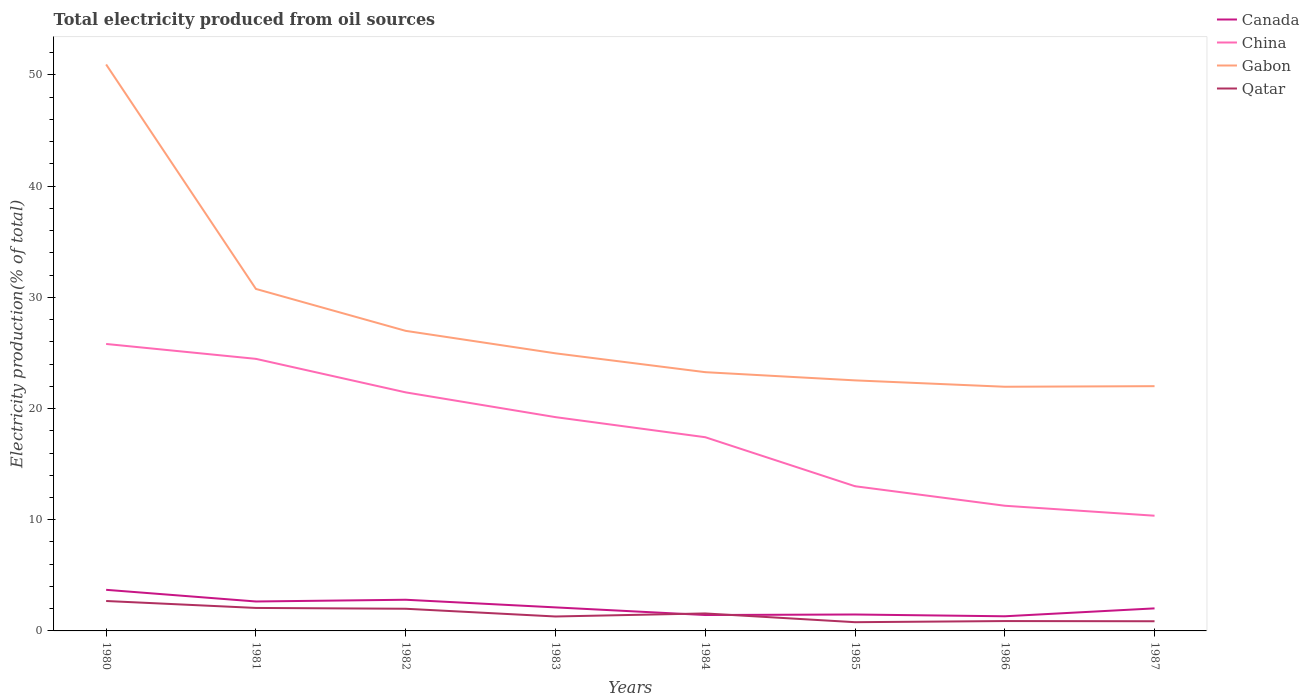How many different coloured lines are there?
Provide a succinct answer. 4. Does the line corresponding to China intersect with the line corresponding to Canada?
Offer a terse response. No. Is the number of lines equal to the number of legend labels?
Offer a very short reply. Yes. Across all years, what is the maximum total electricity produced in Gabon?
Give a very brief answer. 21.96. In which year was the total electricity produced in China maximum?
Offer a very short reply. 1987. What is the total total electricity produced in China in the graph?
Offer a very short reply. 8.87. What is the difference between the highest and the second highest total electricity produced in Canada?
Give a very brief answer. 2.38. Is the total electricity produced in Canada strictly greater than the total electricity produced in China over the years?
Provide a short and direct response. Yes. How many lines are there?
Ensure brevity in your answer.  4. How many years are there in the graph?
Your response must be concise. 8. What is the difference between two consecutive major ticks on the Y-axis?
Your answer should be compact. 10. How many legend labels are there?
Offer a very short reply. 4. What is the title of the graph?
Offer a very short reply. Total electricity produced from oil sources. Does "Jamaica" appear as one of the legend labels in the graph?
Offer a very short reply. No. What is the label or title of the X-axis?
Keep it short and to the point. Years. What is the label or title of the Y-axis?
Your answer should be very brief. Electricity production(% of total). What is the Electricity production(% of total) in Canada in 1980?
Offer a terse response. 3.7. What is the Electricity production(% of total) of China in 1980?
Keep it short and to the point. 25.81. What is the Electricity production(% of total) of Gabon in 1980?
Your answer should be compact. 50.94. What is the Electricity production(% of total) in Qatar in 1980?
Your answer should be compact. 2.69. What is the Electricity production(% of total) of Canada in 1981?
Offer a terse response. 2.65. What is the Electricity production(% of total) in China in 1981?
Provide a short and direct response. 24.47. What is the Electricity production(% of total) in Gabon in 1981?
Your answer should be compact. 30.76. What is the Electricity production(% of total) in Qatar in 1981?
Ensure brevity in your answer.  2.07. What is the Electricity production(% of total) in Canada in 1982?
Offer a terse response. 2.8. What is the Electricity production(% of total) in China in 1982?
Offer a very short reply. 21.45. What is the Electricity production(% of total) in Gabon in 1982?
Give a very brief answer. 26.99. What is the Electricity production(% of total) of Qatar in 1982?
Keep it short and to the point. 1.99. What is the Electricity production(% of total) in Canada in 1983?
Your answer should be compact. 2.12. What is the Electricity production(% of total) of China in 1983?
Provide a succinct answer. 19.23. What is the Electricity production(% of total) of Gabon in 1983?
Your answer should be compact. 24.97. What is the Electricity production(% of total) of Qatar in 1983?
Your answer should be very brief. 1.3. What is the Electricity production(% of total) of Canada in 1984?
Ensure brevity in your answer.  1.43. What is the Electricity production(% of total) of China in 1984?
Ensure brevity in your answer.  17.42. What is the Electricity production(% of total) in Gabon in 1984?
Your response must be concise. 23.27. What is the Electricity production(% of total) in Qatar in 1984?
Give a very brief answer. 1.57. What is the Electricity production(% of total) in Canada in 1985?
Offer a very short reply. 1.48. What is the Electricity production(% of total) in China in 1985?
Your response must be concise. 13.01. What is the Electricity production(% of total) of Gabon in 1985?
Give a very brief answer. 22.53. What is the Electricity production(% of total) in Qatar in 1985?
Offer a very short reply. 0.79. What is the Electricity production(% of total) of Canada in 1986?
Keep it short and to the point. 1.32. What is the Electricity production(% of total) of China in 1986?
Offer a very short reply. 11.26. What is the Electricity production(% of total) in Gabon in 1986?
Your answer should be compact. 21.96. What is the Electricity production(% of total) in Qatar in 1986?
Your answer should be compact. 0.89. What is the Electricity production(% of total) in Canada in 1987?
Your answer should be very brief. 2.03. What is the Electricity production(% of total) in China in 1987?
Provide a short and direct response. 10.36. What is the Electricity production(% of total) of Gabon in 1987?
Your response must be concise. 22.01. What is the Electricity production(% of total) in Qatar in 1987?
Keep it short and to the point. 0.87. Across all years, what is the maximum Electricity production(% of total) of Canada?
Your answer should be compact. 3.7. Across all years, what is the maximum Electricity production(% of total) in China?
Provide a short and direct response. 25.81. Across all years, what is the maximum Electricity production(% of total) of Gabon?
Provide a short and direct response. 50.94. Across all years, what is the maximum Electricity production(% of total) in Qatar?
Provide a succinct answer. 2.69. Across all years, what is the minimum Electricity production(% of total) in Canada?
Ensure brevity in your answer.  1.32. Across all years, what is the minimum Electricity production(% of total) of China?
Your response must be concise. 10.36. Across all years, what is the minimum Electricity production(% of total) of Gabon?
Make the answer very short. 21.96. Across all years, what is the minimum Electricity production(% of total) of Qatar?
Give a very brief answer. 0.79. What is the total Electricity production(% of total) of Canada in the graph?
Make the answer very short. 17.51. What is the total Electricity production(% of total) of China in the graph?
Keep it short and to the point. 143.01. What is the total Electricity production(% of total) of Gabon in the graph?
Provide a short and direct response. 223.42. What is the total Electricity production(% of total) of Qatar in the graph?
Offer a terse response. 12.16. What is the difference between the Electricity production(% of total) in Canada in 1980 and that in 1981?
Your response must be concise. 1.05. What is the difference between the Electricity production(% of total) of China in 1980 and that in 1981?
Ensure brevity in your answer.  1.34. What is the difference between the Electricity production(% of total) in Gabon in 1980 and that in 1981?
Make the answer very short. 20.19. What is the difference between the Electricity production(% of total) of Qatar in 1980 and that in 1981?
Provide a short and direct response. 0.62. What is the difference between the Electricity production(% of total) of Canada in 1980 and that in 1982?
Your answer should be very brief. 0.89. What is the difference between the Electricity production(% of total) in China in 1980 and that in 1982?
Give a very brief answer. 4.35. What is the difference between the Electricity production(% of total) in Gabon in 1980 and that in 1982?
Ensure brevity in your answer.  23.96. What is the difference between the Electricity production(% of total) of Qatar in 1980 and that in 1982?
Make the answer very short. 0.7. What is the difference between the Electricity production(% of total) of Canada in 1980 and that in 1983?
Make the answer very short. 1.58. What is the difference between the Electricity production(% of total) in China in 1980 and that in 1983?
Ensure brevity in your answer.  6.58. What is the difference between the Electricity production(% of total) in Gabon in 1980 and that in 1983?
Make the answer very short. 25.98. What is the difference between the Electricity production(% of total) in Qatar in 1980 and that in 1983?
Offer a very short reply. 1.39. What is the difference between the Electricity production(% of total) of Canada in 1980 and that in 1984?
Ensure brevity in your answer.  2.27. What is the difference between the Electricity production(% of total) of China in 1980 and that in 1984?
Give a very brief answer. 8.39. What is the difference between the Electricity production(% of total) of Gabon in 1980 and that in 1984?
Provide a short and direct response. 27.67. What is the difference between the Electricity production(% of total) in Qatar in 1980 and that in 1984?
Give a very brief answer. 1.12. What is the difference between the Electricity production(% of total) in Canada in 1980 and that in 1985?
Provide a short and direct response. 2.22. What is the difference between the Electricity production(% of total) of China in 1980 and that in 1985?
Your answer should be very brief. 12.79. What is the difference between the Electricity production(% of total) of Gabon in 1980 and that in 1985?
Ensure brevity in your answer.  28.41. What is the difference between the Electricity production(% of total) of Qatar in 1980 and that in 1985?
Give a very brief answer. 1.91. What is the difference between the Electricity production(% of total) of Canada in 1980 and that in 1986?
Give a very brief answer. 2.38. What is the difference between the Electricity production(% of total) of China in 1980 and that in 1986?
Make the answer very short. 14.55. What is the difference between the Electricity production(% of total) of Gabon in 1980 and that in 1986?
Ensure brevity in your answer.  28.98. What is the difference between the Electricity production(% of total) of Qatar in 1980 and that in 1986?
Keep it short and to the point. 1.8. What is the difference between the Electricity production(% of total) in Canada in 1980 and that in 1987?
Offer a very short reply. 1.67. What is the difference between the Electricity production(% of total) in China in 1980 and that in 1987?
Offer a very short reply. 15.45. What is the difference between the Electricity production(% of total) in Gabon in 1980 and that in 1987?
Your response must be concise. 28.93. What is the difference between the Electricity production(% of total) in Qatar in 1980 and that in 1987?
Your answer should be very brief. 1.82. What is the difference between the Electricity production(% of total) in Canada in 1981 and that in 1982?
Provide a succinct answer. -0.16. What is the difference between the Electricity production(% of total) of China in 1981 and that in 1982?
Give a very brief answer. 3.01. What is the difference between the Electricity production(% of total) in Gabon in 1981 and that in 1982?
Offer a very short reply. 3.77. What is the difference between the Electricity production(% of total) in Qatar in 1981 and that in 1982?
Make the answer very short. 0.07. What is the difference between the Electricity production(% of total) in Canada in 1981 and that in 1983?
Your answer should be very brief. 0.53. What is the difference between the Electricity production(% of total) in China in 1981 and that in 1983?
Your answer should be compact. 5.24. What is the difference between the Electricity production(% of total) of Gabon in 1981 and that in 1983?
Make the answer very short. 5.79. What is the difference between the Electricity production(% of total) of Qatar in 1981 and that in 1983?
Your answer should be compact. 0.77. What is the difference between the Electricity production(% of total) of Canada in 1981 and that in 1984?
Offer a terse response. 1.22. What is the difference between the Electricity production(% of total) in China in 1981 and that in 1984?
Provide a succinct answer. 7.05. What is the difference between the Electricity production(% of total) of Gabon in 1981 and that in 1984?
Give a very brief answer. 7.49. What is the difference between the Electricity production(% of total) in Qatar in 1981 and that in 1984?
Keep it short and to the point. 0.5. What is the difference between the Electricity production(% of total) of Canada in 1981 and that in 1985?
Your response must be concise. 1.17. What is the difference between the Electricity production(% of total) of China in 1981 and that in 1985?
Offer a very short reply. 11.46. What is the difference between the Electricity production(% of total) of Gabon in 1981 and that in 1985?
Your answer should be very brief. 8.22. What is the difference between the Electricity production(% of total) of Qatar in 1981 and that in 1985?
Give a very brief answer. 1.28. What is the difference between the Electricity production(% of total) in Canada in 1981 and that in 1986?
Your answer should be compact. 1.33. What is the difference between the Electricity production(% of total) of China in 1981 and that in 1986?
Provide a succinct answer. 13.21. What is the difference between the Electricity production(% of total) in Gabon in 1981 and that in 1986?
Provide a succinct answer. 8.8. What is the difference between the Electricity production(% of total) of Qatar in 1981 and that in 1986?
Ensure brevity in your answer.  1.18. What is the difference between the Electricity production(% of total) in Canada in 1981 and that in 1987?
Offer a terse response. 0.62. What is the difference between the Electricity production(% of total) of China in 1981 and that in 1987?
Provide a succinct answer. 14.11. What is the difference between the Electricity production(% of total) of Gabon in 1981 and that in 1987?
Your response must be concise. 8.75. What is the difference between the Electricity production(% of total) in Qatar in 1981 and that in 1987?
Provide a succinct answer. 1.2. What is the difference between the Electricity production(% of total) in Canada in 1982 and that in 1983?
Provide a short and direct response. 0.69. What is the difference between the Electricity production(% of total) in China in 1982 and that in 1983?
Make the answer very short. 2.23. What is the difference between the Electricity production(% of total) of Gabon in 1982 and that in 1983?
Keep it short and to the point. 2.02. What is the difference between the Electricity production(% of total) in Qatar in 1982 and that in 1983?
Keep it short and to the point. 0.7. What is the difference between the Electricity production(% of total) of Canada in 1982 and that in 1984?
Your answer should be compact. 1.37. What is the difference between the Electricity production(% of total) in China in 1982 and that in 1984?
Provide a short and direct response. 4.03. What is the difference between the Electricity production(% of total) in Gabon in 1982 and that in 1984?
Provide a short and direct response. 3.72. What is the difference between the Electricity production(% of total) of Qatar in 1982 and that in 1984?
Make the answer very short. 0.42. What is the difference between the Electricity production(% of total) in Canada in 1982 and that in 1985?
Ensure brevity in your answer.  1.33. What is the difference between the Electricity production(% of total) in China in 1982 and that in 1985?
Provide a succinct answer. 8.44. What is the difference between the Electricity production(% of total) of Gabon in 1982 and that in 1985?
Your response must be concise. 4.45. What is the difference between the Electricity production(% of total) in Qatar in 1982 and that in 1985?
Offer a very short reply. 1.21. What is the difference between the Electricity production(% of total) in Canada in 1982 and that in 1986?
Ensure brevity in your answer.  1.49. What is the difference between the Electricity production(% of total) of China in 1982 and that in 1986?
Offer a very short reply. 10.2. What is the difference between the Electricity production(% of total) of Gabon in 1982 and that in 1986?
Offer a terse response. 5.03. What is the difference between the Electricity production(% of total) of Qatar in 1982 and that in 1986?
Offer a very short reply. 1.11. What is the difference between the Electricity production(% of total) in Canada in 1982 and that in 1987?
Provide a succinct answer. 0.78. What is the difference between the Electricity production(% of total) in China in 1982 and that in 1987?
Give a very brief answer. 11.09. What is the difference between the Electricity production(% of total) of Gabon in 1982 and that in 1987?
Offer a terse response. 4.98. What is the difference between the Electricity production(% of total) of Qatar in 1982 and that in 1987?
Provide a succinct answer. 1.12. What is the difference between the Electricity production(% of total) in Canada in 1983 and that in 1984?
Provide a succinct answer. 0.69. What is the difference between the Electricity production(% of total) of China in 1983 and that in 1984?
Offer a terse response. 1.81. What is the difference between the Electricity production(% of total) of Gabon in 1983 and that in 1984?
Ensure brevity in your answer.  1.7. What is the difference between the Electricity production(% of total) of Qatar in 1983 and that in 1984?
Keep it short and to the point. -0.27. What is the difference between the Electricity production(% of total) of Canada in 1983 and that in 1985?
Your answer should be compact. 0.64. What is the difference between the Electricity production(% of total) of China in 1983 and that in 1985?
Offer a very short reply. 6.21. What is the difference between the Electricity production(% of total) in Gabon in 1983 and that in 1985?
Offer a terse response. 2.43. What is the difference between the Electricity production(% of total) in Qatar in 1983 and that in 1985?
Ensure brevity in your answer.  0.51. What is the difference between the Electricity production(% of total) of Canada in 1983 and that in 1986?
Offer a terse response. 0.8. What is the difference between the Electricity production(% of total) in China in 1983 and that in 1986?
Ensure brevity in your answer.  7.97. What is the difference between the Electricity production(% of total) of Gabon in 1983 and that in 1986?
Give a very brief answer. 3.01. What is the difference between the Electricity production(% of total) in Qatar in 1983 and that in 1986?
Your answer should be compact. 0.41. What is the difference between the Electricity production(% of total) of Canada in 1983 and that in 1987?
Make the answer very short. 0.09. What is the difference between the Electricity production(% of total) of China in 1983 and that in 1987?
Keep it short and to the point. 8.87. What is the difference between the Electricity production(% of total) in Gabon in 1983 and that in 1987?
Ensure brevity in your answer.  2.95. What is the difference between the Electricity production(% of total) in Qatar in 1983 and that in 1987?
Offer a very short reply. 0.43. What is the difference between the Electricity production(% of total) in Canada in 1984 and that in 1985?
Offer a terse response. -0.05. What is the difference between the Electricity production(% of total) of China in 1984 and that in 1985?
Offer a terse response. 4.41. What is the difference between the Electricity production(% of total) of Gabon in 1984 and that in 1985?
Provide a succinct answer. 0.74. What is the difference between the Electricity production(% of total) of Qatar in 1984 and that in 1985?
Provide a short and direct response. 0.79. What is the difference between the Electricity production(% of total) of Canada in 1984 and that in 1986?
Provide a short and direct response. 0.11. What is the difference between the Electricity production(% of total) of China in 1984 and that in 1986?
Offer a very short reply. 6.16. What is the difference between the Electricity production(% of total) of Gabon in 1984 and that in 1986?
Your answer should be very brief. 1.31. What is the difference between the Electricity production(% of total) in Qatar in 1984 and that in 1986?
Your answer should be very brief. 0.69. What is the difference between the Electricity production(% of total) in Canada in 1984 and that in 1987?
Provide a short and direct response. -0.6. What is the difference between the Electricity production(% of total) in China in 1984 and that in 1987?
Provide a succinct answer. 7.06. What is the difference between the Electricity production(% of total) of Gabon in 1984 and that in 1987?
Your answer should be very brief. 1.26. What is the difference between the Electricity production(% of total) of Qatar in 1984 and that in 1987?
Keep it short and to the point. 0.7. What is the difference between the Electricity production(% of total) of Canada in 1985 and that in 1986?
Your answer should be compact. 0.16. What is the difference between the Electricity production(% of total) of China in 1985 and that in 1986?
Your answer should be very brief. 1.76. What is the difference between the Electricity production(% of total) in Gabon in 1985 and that in 1986?
Provide a short and direct response. 0.57. What is the difference between the Electricity production(% of total) in Qatar in 1985 and that in 1986?
Offer a terse response. -0.1. What is the difference between the Electricity production(% of total) in Canada in 1985 and that in 1987?
Keep it short and to the point. -0.55. What is the difference between the Electricity production(% of total) of China in 1985 and that in 1987?
Offer a very short reply. 2.65. What is the difference between the Electricity production(% of total) of Gabon in 1985 and that in 1987?
Your answer should be compact. 0.52. What is the difference between the Electricity production(% of total) of Qatar in 1985 and that in 1987?
Offer a terse response. -0.09. What is the difference between the Electricity production(% of total) in Canada in 1986 and that in 1987?
Give a very brief answer. -0.71. What is the difference between the Electricity production(% of total) in China in 1986 and that in 1987?
Make the answer very short. 0.9. What is the difference between the Electricity production(% of total) in Gabon in 1986 and that in 1987?
Ensure brevity in your answer.  -0.05. What is the difference between the Electricity production(% of total) in Qatar in 1986 and that in 1987?
Offer a terse response. 0.02. What is the difference between the Electricity production(% of total) of Canada in 1980 and the Electricity production(% of total) of China in 1981?
Provide a short and direct response. -20.77. What is the difference between the Electricity production(% of total) of Canada in 1980 and the Electricity production(% of total) of Gabon in 1981?
Your answer should be compact. -27.06. What is the difference between the Electricity production(% of total) of Canada in 1980 and the Electricity production(% of total) of Qatar in 1981?
Make the answer very short. 1.63. What is the difference between the Electricity production(% of total) of China in 1980 and the Electricity production(% of total) of Gabon in 1981?
Your answer should be compact. -4.95. What is the difference between the Electricity production(% of total) of China in 1980 and the Electricity production(% of total) of Qatar in 1981?
Make the answer very short. 23.74. What is the difference between the Electricity production(% of total) of Gabon in 1980 and the Electricity production(% of total) of Qatar in 1981?
Offer a terse response. 48.88. What is the difference between the Electricity production(% of total) in Canada in 1980 and the Electricity production(% of total) in China in 1982?
Your response must be concise. -17.76. What is the difference between the Electricity production(% of total) in Canada in 1980 and the Electricity production(% of total) in Gabon in 1982?
Give a very brief answer. -23.29. What is the difference between the Electricity production(% of total) of Canada in 1980 and the Electricity production(% of total) of Qatar in 1982?
Your response must be concise. 1.7. What is the difference between the Electricity production(% of total) of China in 1980 and the Electricity production(% of total) of Gabon in 1982?
Keep it short and to the point. -1.18. What is the difference between the Electricity production(% of total) of China in 1980 and the Electricity production(% of total) of Qatar in 1982?
Your answer should be compact. 23.81. What is the difference between the Electricity production(% of total) in Gabon in 1980 and the Electricity production(% of total) in Qatar in 1982?
Offer a terse response. 48.95. What is the difference between the Electricity production(% of total) of Canada in 1980 and the Electricity production(% of total) of China in 1983?
Keep it short and to the point. -15.53. What is the difference between the Electricity production(% of total) of Canada in 1980 and the Electricity production(% of total) of Gabon in 1983?
Make the answer very short. -21.27. What is the difference between the Electricity production(% of total) in Canada in 1980 and the Electricity production(% of total) in Qatar in 1983?
Give a very brief answer. 2.4. What is the difference between the Electricity production(% of total) of China in 1980 and the Electricity production(% of total) of Gabon in 1983?
Provide a succinct answer. 0.84. What is the difference between the Electricity production(% of total) in China in 1980 and the Electricity production(% of total) in Qatar in 1983?
Make the answer very short. 24.51. What is the difference between the Electricity production(% of total) of Gabon in 1980 and the Electricity production(% of total) of Qatar in 1983?
Your answer should be compact. 49.65. What is the difference between the Electricity production(% of total) of Canada in 1980 and the Electricity production(% of total) of China in 1984?
Make the answer very short. -13.73. What is the difference between the Electricity production(% of total) of Canada in 1980 and the Electricity production(% of total) of Gabon in 1984?
Your response must be concise. -19.57. What is the difference between the Electricity production(% of total) in Canada in 1980 and the Electricity production(% of total) in Qatar in 1984?
Offer a terse response. 2.12. What is the difference between the Electricity production(% of total) in China in 1980 and the Electricity production(% of total) in Gabon in 1984?
Offer a terse response. 2.54. What is the difference between the Electricity production(% of total) in China in 1980 and the Electricity production(% of total) in Qatar in 1984?
Keep it short and to the point. 24.24. What is the difference between the Electricity production(% of total) of Gabon in 1980 and the Electricity production(% of total) of Qatar in 1984?
Ensure brevity in your answer.  49.37. What is the difference between the Electricity production(% of total) of Canada in 1980 and the Electricity production(% of total) of China in 1985?
Provide a short and direct response. -9.32. What is the difference between the Electricity production(% of total) of Canada in 1980 and the Electricity production(% of total) of Gabon in 1985?
Your response must be concise. -18.84. What is the difference between the Electricity production(% of total) in Canada in 1980 and the Electricity production(% of total) in Qatar in 1985?
Your response must be concise. 2.91. What is the difference between the Electricity production(% of total) in China in 1980 and the Electricity production(% of total) in Gabon in 1985?
Offer a very short reply. 3.27. What is the difference between the Electricity production(% of total) of China in 1980 and the Electricity production(% of total) of Qatar in 1985?
Your response must be concise. 25.02. What is the difference between the Electricity production(% of total) in Gabon in 1980 and the Electricity production(% of total) in Qatar in 1985?
Keep it short and to the point. 50.16. What is the difference between the Electricity production(% of total) of Canada in 1980 and the Electricity production(% of total) of China in 1986?
Ensure brevity in your answer.  -7.56. What is the difference between the Electricity production(% of total) of Canada in 1980 and the Electricity production(% of total) of Gabon in 1986?
Offer a very short reply. -18.26. What is the difference between the Electricity production(% of total) of Canada in 1980 and the Electricity production(% of total) of Qatar in 1986?
Provide a succinct answer. 2.81. What is the difference between the Electricity production(% of total) in China in 1980 and the Electricity production(% of total) in Gabon in 1986?
Provide a short and direct response. 3.85. What is the difference between the Electricity production(% of total) in China in 1980 and the Electricity production(% of total) in Qatar in 1986?
Make the answer very short. 24.92. What is the difference between the Electricity production(% of total) in Gabon in 1980 and the Electricity production(% of total) in Qatar in 1986?
Offer a very short reply. 50.06. What is the difference between the Electricity production(% of total) of Canada in 1980 and the Electricity production(% of total) of China in 1987?
Keep it short and to the point. -6.66. What is the difference between the Electricity production(% of total) in Canada in 1980 and the Electricity production(% of total) in Gabon in 1987?
Provide a short and direct response. -18.31. What is the difference between the Electricity production(% of total) in Canada in 1980 and the Electricity production(% of total) in Qatar in 1987?
Offer a very short reply. 2.83. What is the difference between the Electricity production(% of total) in China in 1980 and the Electricity production(% of total) in Gabon in 1987?
Make the answer very short. 3.8. What is the difference between the Electricity production(% of total) of China in 1980 and the Electricity production(% of total) of Qatar in 1987?
Ensure brevity in your answer.  24.94. What is the difference between the Electricity production(% of total) of Gabon in 1980 and the Electricity production(% of total) of Qatar in 1987?
Give a very brief answer. 50.07. What is the difference between the Electricity production(% of total) in Canada in 1981 and the Electricity production(% of total) in China in 1982?
Provide a short and direct response. -18.81. What is the difference between the Electricity production(% of total) in Canada in 1981 and the Electricity production(% of total) in Gabon in 1982?
Offer a very short reply. -24.34. What is the difference between the Electricity production(% of total) in Canada in 1981 and the Electricity production(% of total) in Qatar in 1982?
Provide a short and direct response. 0.65. What is the difference between the Electricity production(% of total) in China in 1981 and the Electricity production(% of total) in Gabon in 1982?
Provide a short and direct response. -2.52. What is the difference between the Electricity production(% of total) in China in 1981 and the Electricity production(% of total) in Qatar in 1982?
Provide a short and direct response. 22.47. What is the difference between the Electricity production(% of total) of Gabon in 1981 and the Electricity production(% of total) of Qatar in 1982?
Your response must be concise. 28.76. What is the difference between the Electricity production(% of total) of Canada in 1981 and the Electricity production(% of total) of China in 1983?
Provide a short and direct response. -16.58. What is the difference between the Electricity production(% of total) in Canada in 1981 and the Electricity production(% of total) in Gabon in 1983?
Offer a very short reply. -22.32. What is the difference between the Electricity production(% of total) in Canada in 1981 and the Electricity production(% of total) in Qatar in 1983?
Your response must be concise. 1.35. What is the difference between the Electricity production(% of total) in China in 1981 and the Electricity production(% of total) in Gabon in 1983?
Offer a very short reply. -0.5. What is the difference between the Electricity production(% of total) in China in 1981 and the Electricity production(% of total) in Qatar in 1983?
Offer a terse response. 23.17. What is the difference between the Electricity production(% of total) in Gabon in 1981 and the Electricity production(% of total) in Qatar in 1983?
Your answer should be very brief. 29.46. What is the difference between the Electricity production(% of total) in Canada in 1981 and the Electricity production(% of total) in China in 1984?
Your answer should be compact. -14.77. What is the difference between the Electricity production(% of total) in Canada in 1981 and the Electricity production(% of total) in Gabon in 1984?
Offer a terse response. -20.62. What is the difference between the Electricity production(% of total) in Canada in 1981 and the Electricity production(% of total) in Qatar in 1984?
Make the answer very short. 1.08. What is the difference between the Electricity production(% of total) of China in 1981 and the Electricity production(% of total) of Gabon in 1984?
Offer a terse response. 1.2. What is the difference between the Electricity production(% of total) of China in 1981 and the Electricity production(% of total) of Qatar in 1984?
Your response must be concise. 22.9. What is the difference between the Electricity production(% of total) in Gabon in 1981 and the Electricity production(% of total) in Qatar in 1984?
Give a very brief answer. 29.18. What is the difference between the Electricity production(% of total) of Canada in 1981 and the Electricity production(% of total) of China in 1985?
Your response must be concise. -10.37. What is the difference between the Electricity production(% of total) of Canada in 1981 and the Electricity production(% of total) of Gabon in 1985?
Provide a succinct answer. -19.88. What is the difference between the Electricity production(% of total) of Canada in 1981 and the Electricity production(% of total) of Qatar in 1985?
Your response must be concise. 1.86. What is the difference between the Electricity production(% of total) of China in 1981 and the Electricity production(% of total) of Gabon in 1985?
Your answer should be compact. 1.94. What is the difference between the Electricity production(% of total) of China in 1981 and the Electricity production(% of total) of Qatar in 1985?
Offer a terse response. 23.68. What is the difference between the Electricity production(% of total) of Gabon in 1981 and the Electricity production(% of total) of Qatar in 1985?
Ensure brevity in your answer.  29.97. What is the difference between the Electricity production(% of total) of Canada in 1981 and the Electricity production(% of total) of China in 1986?
Offer a very short reply. -8.61. What is the difference between the Electricity production(% of total) of Canada in 1981 and the Electricity production(% of total) of Gabon in 1986?
Your answer should be very brief. -19.31. What is the difference between the Electricity production(% of total) of Canada in 1981 and the Electricity production(% of total) of Qatar in 1986?
Make the answer very short. 1.76. What is the difference between the Electricity production(% of total) in China in 1981 and the Electricity production(% of total) in Gabon in 1986?
Keep it short and to the point. 2.51. What is the difference between the Electricity production(% of total) in China in 1981 and the Electricity production(% of total) in Qatar in 1986?
Your response must be concise. 23.58. What is the difference between the Electricity production(% of total) in Gabon in 1981 and the Electricity production(% of total) in Qatar in 1986?
Your response must be concise. 29.87. What is the difference between the Electricity production(% of total) in Canada in 1981 and the Electricity production(% of total) in China in 1987?
Offer a very short reply. -7.71. What is the difference between the Electricity production(% of total) in Canada in 1981 and the Electricity production(% of total) in Gabon in 1987?
Offer a terse response. -19.36. What is the difference between the Electricity production(% of total) of Canada in 1981 and the Electricity production(% of total) of Qatar in 1987?
Provide a short and direct response. 1.78. What is the difference between the Electricity production(% of total) in China in 1981 and the Electricity production(% of total) in Gabon in 1987?
Provide a short and direct response. 2.46. What is the difference between the Electricity production(% of total) of China in 1981 and the Electricity production(% of total) of Qatar in 1987?
Your answer should be compact. 23.6. What is the difference between the Electricity production(% of total) of Gabon in 1981 and the Electricity production(% of total) of Qatar in 1987?
Provide a short and direct response. 29.89. What is the difference between the Electricity production(% of total) in Canada in 1982 and the Electricity production(% of total) in China in 1983?
Your answer should be very brief. -16.42. What is the difference between the Electricity production(% of total) of Canada in 1982 and the Electricity production(% of total) of Gabon in 1983?
Ensure brevity in your answer.  -22.16. What is the difference between the Electricity production(% of total) in Canada in 1982 and the Electricity production(% of total) in Qatar in 1983?
Ensure brevity in your answer.  1.51. What is the difference between the Electricity production(% of total) of China in 1982 and the Electricity production(% of total) of Gabon in 1983?
Ensure brevity in your answer.  -3.51. What is the difference between the Electricity production(% of total) in China in 1982 and the Electricity production(% of total) in Qatar in 1983?
Your answer should be very brief. 20.16. What is the difference between the Electricity production(% of total) in Gabon in 1982 and the Electricity production(% of total) in Qatar in 1983?
Keep it short and to the point. 25.69. What is the difference between the Electricity production(% of total) in Canada in 1982 and the Electricity production(% of total) in China in 1984?
Provide a short and direct response. -14.62. What is the difference between the Electricity production(% of total) in Canada in 1982 and the Electricity production(% of total) in Gabon in 1984?
Keep it short and to the point. -20.47. What is the difference between the Electricity production(% of total) of Canada in 1982 and the Electricity production(% of total) of Qatar in 1984?
Keep it short and to the point. 1.23. What is the difference between the Electricity production(% of total) in China in 1982 and the Electricity production(% of total) in Gabon in 1984?
Make the answer very short. -1.82. What is the difference between the Electricity production(% of total) of China in 1982 and the Electricity production(% of total) of Qatar in 1984?
Make the answer very short. 19.88. What is the difference between the Electricity production(% of total) of Gabon in 1982 and the Electricity production(% of total) of Qatar in 1984?
Provide a succinct answer. 25.41. What is the difference between the Electricity production(% of total) of Canada in 1982 and the Electricity production(% of total) of China in 1985?
Give a very brief answer. -10.21. What is the difference between the Electricity production(% of total) of Canada in 1982 and the Electricity production(% of total) of Gabon in 1985?
Give a very brief answer. -19.73. What is the difference between the Electricity production(% of total) in Canada in 1982 and the Electricity production(% of total) in Qatar in 1985?
Your answer should be very brief. 2.02. What is the difference between the Electricity production(% of total) of China in 1982 and the Electricity production(% of total) of Gabon in 1985?
Give a very brief answer. -1.08. What is the difference between the Electricity production(% of total) of China in 1982 and the Electricity production(% of total) of Qatar in 1985?
Offer a very short reply. 20.67. What is the difference between the Electricity production(% of total) of Gabon in 1982 and the Electricity production(% of total) of Qatar in 1985?
Your answer should be compact. 26.2. What is the difference between the Electricity production(% of total) of Canada in 1982 and the Electricity production(% of total) of China in 1986?
Your answer should be compact. -8.45. What is the difference between the Electricity production(% of total) of Canada in 1982 and the Electricity production(% of total) of Gabon in 1986?
Keep it short and to the point. -19.16. What is the difference between the Electricity production(% of total) of Canada in 1982 and the Electricity production(% of total) of Qatar in 1986?
Your response must be concise. 1.92. What is the difference between the Electricity production(% of total) of China in 1982 and the Electricity production(% of total) of Gabon in 1986?
Offer a terse response. -0.51. What is the difference between the Electricity production(% of total) in China in 1982 and the Electricity production(% of total) in Qatar in 1986?
Provide a succinct answer. 20.57. What is the difference between the Electricity production(% of total) of Gabon in 1982 and the Electricity production(% of total) of Qatar in 1986?
Keep it short and to the point. 26.1. What is the difference between the Electricity production(% of total) of Canada in 1982 and the Electricity production(% of total) of China in 1987?
Your response must be concise. -7.56. What is the difference between the Electricity production(% of total) in Canada in 1982 and the Electricity production(% of total) in Gabon in 1987?
Make the answer very short. -19.21. What is the difference between the Electricity production(% of total) in Canada in 1982 and the Electricity production(% of total) in Qatar in 1987?
Ensure brevity in your answer.  1.93. What is the difference between the Electricity production(% of total) in China in 1982 and the Electricity production(% of total) in Gabon in 1987?
Give a very brief answer. -0.56. What is the difference between the Electricity production(% of total) of China in 1982 and the Electricity production(% of total) of Qatar in 1987?
Your answer should be compact. 20.58. What is the difference between the Electricity production(% of total) of Gabon in 1982 and the Electricity production(% of total) of Qatar in 1987?
Your answer should be compact. 26.12. What is the difference between the Electricity production(% of total) in Canada in 1983 and the Electricity production(% of total) in China in 1984?
Keep it short and to the point. -15.31. What is the difference between the Electricity production(% of total) in Canada in 1983 and the Electricity production(% of total) in Gabon in 1984?
Your answer should be compact. -21.15. What is the difference between the Electricity production(% of total) in Canada in 1983 and the Electricity production(% of total) in Qatar in 1984?
Provide a short and direct response. 0.54. What is the difference between the Electricity production(% of total) in China in 1983 and the Electricity production(% of total) in Gabon in 1984?
Provide a succinct answer. -4.04. What is the difference between the Electricity production(% of total) in China in 1983 and the Electricity production(% of total) in Qatar in 1984?
Give a very brief answer. 17.66. What is the difference between the Electricity production(% of total) of Gabon in 1983 and the Electricity production(% of total) of Qatar in 1984?
Give a very brief answer. 23.39. What is the difference between the Electricity production(% of total) of Canada in 1983 and the Electricity production(% of total) of China in 1985?
Give a very brief answer. -10.9. What is the difference between the Electricity production(% of total) of Canada in 1983 and the Electricity production(% of total) of Gabon in 1985?
Your answer should be compact. -20.42. What is the difference between the Electricity production(% of total) in Canada in 1983 and the Electricity production(% of total) in Qatar in 1985?
Provide a succinct answer. 1.33. What is the difference between the Electricity production(% of total) of China in 1983 and the Electricity production(% of total) of Gabon in 1985?
Offer a very short reply. -3.31. What is the difference between the Electricity production(% of total) in China in 1983 and the Electricity production(% of total) in Qatar in 1985?
Keep it short and to the point. 18.44. What is the difference between the Electricity production(% of total) in Gabon in 1983 and the Electricity production(% of total) in Qatar in 1985?
Your answer should be compact. 24.18. What is the difference between the Electricity production(% of total) of Canada in 1983 and the Electricity production(% of total) of China in 1986?
Make the answer very short. -9.14. What is the difference between the Electricity production(% of total) in Canada in 1983 and the Electricity production(% of total) in Gabon in 1986?
Provide a succinct answer. -19.84. What is the difference between the Electricity production(% of total) of Canada in 1983 and the Electricity production(% of total) of Qatar in 1986?
Provide a succinct answer. 1.23. What is the difference between the Electricity production(% of total) of China in 1983 and the Electricity production(% of total) of Gabon in 1986?
Your answer should be very brief. -2.73. What is the difference between the Electricity production(% of total) of China in 1983 and the Electricity production(% of total) of Qatar in 1986?
Offer a terse response. 18.34. What is the difference between the Electricity production(% of total) in Gabon in 1983 and the Electricity production(% of total) in Qatar in 1986?
Provide a short and direct response. 24.08. What is the difference between the Electricity production(% of total) in Canada in 1983 and the Electricity production(% of total) in China in 1987?
Your answer should be compact. -8.24. What is the difference between the Electricity production(% of total) of Canada in 1983 and the Electricity production(% of total) of Gabon in 1987?
Keep it short and to the point. -19.9. What is the difference between the Electricity production(% of total) of Canada in 1983 and the Electricity production(% of total) of Qatar in 1987?
Offer a very short reply. 1.25. What is the difference between the Electricity production(% of total) in China in 1983 and the Electricity production(% of total) in Gabon in 1987?
Your response must be concise. -2.78. What is the difference between the Electricity production(% of total) of China in 1983 and the Electricity production(% of total) of Qatar in 1987?
Your answer should be compact. 18.36. What is the difference between the Electricity production(% of total) of Gabon in 1983 and the Electricity production(% of total) of Qatar in 1987?
Your answer should be very brief. 24.1. What is the difference between the Electricity production(% of total) in Canada in 1984 and the Electricity production(% of total) in China in 1985?
Provide a succinct answer. -11.58. What is the difference between the Electricity production(% of total) in Canada in 1984 and the Electricity production(% of total) in Gabon in 1985?
Ensure brevity in your answer.  -21.1. What is the difference between the Electricity production(% of total) of Canada in 1984 and the Electricity production(% of total) of Qatar in 1985?
Your response must be concise. 0.65. What is the difference between the Electricity production(% of total) in China in 1984 and the Electricity production(% of total) in Gabon in 1985?
Give a very brief answer. -5.11. What is the difference between the Electricity production(% of total) in China in 1984 and the Electricity production(% of total) in Qatar in 1985?
Keep it short and to the point. 16.64. What is the difference between the Electricity production(% of total) of Gabon in 1984 and the Electricity production(% of total) of Qatar in 1985?
Offer a terse response. 22.49. What is the difference between the Electricity production(% of total) of Canada in 1984 and the Electricity production(% of total) of China in 1986?
Offer a very short reply. -9.83. What is the difference between the Electricity production(% of total) of Canada in 1984 and the Electricity production(% of total) of Gabon in 1986?
Offer a very short reply. -20.53. What is the difference between the Electricity production(% of total) of Canada in 1984 and the Electricity production(% of total) of Qatar in 1986?
Give a very brief answer. 0.54. What is the difference between the Electricity production(% of total) of China in 1984 and the Electricity production(% of total) of Gabon in 1986?
Offer a terse response. -4.54. What is the difference between the Electricity production(% of total) in China in 1984 and the Electricity production(% of total) in Qatar in 1986?
Your response must be concise. 16.54. What is the difference between the Electricity production(% of total) in Gabon in 1984 and the Electricity production(% of total) in Qatar in 1986?
Your answer should be compact. 22.38. What is the difference between the Electricity production(% of total) in Canada in 1984 and the Electricity production(% of total) in China in 1987?
Make the answer very short. -8.93. What is the difference between the Electricity production(% of total) in Canada in 1984 and the Electricity production(% of total) in Gabon in 1987?
Provide a succinct answer. -20.58. What is the difference between the Electricity production(% of total) in Canada in 1984 and the Electricity production(% of total) in Qatar in 1987?
Ensure brevity in your answer.  0.56. What is the difference between the Electricity production(% of total) in China in 1984 and the Electricity production(% of total) in Gabon in 1987?
Ensure brevity in your answer.  -4.59. What is the difference between the Electricity production(% of total) of China in 1984 and the Electricity production(% of total) of Qatar in 1987?
Your response must be concise. 16.55. What is the difference between the Electricity production(% of total) in Gabon in 1984 and the Electricity production(% of total) in Qatar in 1987?
Offer a very short reply. 22.4. What is the difference between the Electricity production(% of total) in Canada in 1985 and the Electricity production(% of total) in China in 1986?
Keep it short and to the point. -9.78. What is the difference between the Electricity production(% of total) in Canada in 1985 and the Electricity production(% of total) in Gabon in 1986?
Provide a short and direct response. -20.48. What is the difference between the Electricity production(% of total) in Canada in 1985 and the Electricity production(% of total) in Qatar in 1986?
Give a very brief answer. 0.59. What is the difference between the Electricity production(% of total) of China in 1985 and the Electricity production(% of total) of Gabon in 1986?
Make the answer very short. -8.95. What is the difference between the Electricity production(% of total) of China in 1985 and the Electricity production(% of total) of Qatar in 1986?
Provide a succinct answer. 12.13. What is the difference between the Electricity production(% of total) of Gabon in 1985 and the Electricity production(% of total) of Qatar in 1986?
Your answer should be very brief. 21.65. What is the difference between the Electricity production(% of total) in Canada in 1985 and the Electricity production(% of total) in China in 1987?
Give a very brief answer. -8.88. What is the difference between the Electricity production(% of total) of Canada in 1985 and the Electricity production(% of total) of Gabon in 1987?
Your answer should be compact. -20.53. What is the difference between the Electricity production(% of total) in Canada in 1985 and the Electricity production(% of total) in Qatar in 1987?
Your answer should be very brief. 0.61. What is the difference between the Electricity production(% of total) in China in 1985 and the Electricity production(% of total) in Gabon in 1987?
Offer a very short reply. -9. What is the difference between the Electricity production(% of total) of China in 1985 and the Electricity production(% of total) of Qatar in 1987?
Provide a succinct answer. 12.14. What is the difference between the Electricity production(% of total) in Gabon in 1985 and the Electricity production(% of total) in Qatar in 1987?
Your answer should be compact. 21.66. What is the difference between the Electricity production(% of total) of Canada in 1986 and the Electricity production(% of total) of China in 1987?
Offer a very short reply. -9.04. What is the difference between the Electricity production(% of total) of Canada in 1986 and the Electricity production(% of total) of Gabon in 1987?
Give a very brief answer. -20.7. What is the difference between the Electricity production(% of total) in Canada in 1986 and the Electricity production(% of total) in Qatar in 1987?
Your response must be concise. 0.45. What is the difference between the Electricity production(% of total) in China in 1986 and the Electricity production(% of total) in Gabon in 1987?
Provide a short and direct response. -10.75. What is the difference between the Electricity production(% of total) of China in 1986 and the Electricity production(% of total) of Qatar in 1987?
Provide a succinct answer. 10.39. What is the difference between the Electricity production(% of total) in Gabon in 1986 and the Electricity production(% of total) in Qatar in 1987?
Give a very brief answer. 21.09. What is the average Electricity production(% of total) in Canada per year?
Ensure brevity in your answer.  2.19. What is the average Electricity production(% of total) in China per year?
Make the answer very short. 17.88. What is the average Electricity production(% of total) in Gabon per year?
Offer a terse response. 27.93. What is the average Electricity production(% of total) in Qatar per year?
Ensure brevity in your answer.  1.52. In the year 1980, what is the difference between the Electricity production(% of total) of Canada and Electricity production(% of total) of China?
Give a very brief answer. -22.11. In the year 1980, what is the difference between the Electricity production(% of total) in Canada and Electricity production(% of total) in Gabon?
Make the answer very short. -47.25. In the year 1980, what is the difference between the Electricity production(% of total) of China and Electricity production(% of total) of Gabon?
Offer a very short reply. -25.14. In the year 1980, what is the difference between the Electricity production(% of total) of China and Electricity production(% of total) of Qatar?
Offer a terse response. 23.12. In the year 1980, what is the difference between the Electricity production(% of total) in Gabon and Electricity production(% of total) in Qatar?
Offer a terse response. 48.25. In the year 1981, what is the difference between the Electricity production(% of total) in Canada and Electricity production(% of total) in China?
Provide a succinct answer. -21.82. In the year 1981, what is the difference between the Electricity production(% of total) in Canada and Electricity production(% of total) in Gabon?
Make the answer very short. -28.11. In the year 1981, what is the difference between the Electricity production(% of total) in Canada and Electricity production(% of total) in Qatar?
Offer a very short reply. 0.58. In the year 1981, what is the difference between the Electricity production(% of total) of China and Electricity production(% of total) of Gabon?
Offer a very short reply. -6.29. In the year 1981, what is the difference between the Electricity production(% of total) of China and Electricity production(% of total) of Qatar?
Offer a terse response. 22.4. In the year 1981, what is the difference between the Electricity production(% of total) in Gabon and Electricity production(% of total) in Qatar?
Provide a short and direct response. 28.69. In the year 1982, what is the difference between the Electricity production(% of total) in Canada and Electricity production(% of total) in China?
Provide a short and direct response. -18.65. In the year 1982, what is the difference between the Electricity production(% of total) of Canada and Electricity production(% of total) of Gabon?
Offer a very short reply. -24.18. In the year 1982, what is the difference between the Electricity production(% of total) in Canada and Electricity production(% of total) in Qatar?
Offer a terse response. 0.81. In the year 1982, what is the difference between the Electricity production(% of total) in China and Electricity production(% of total) in Gabon?
Your answer should be compact. -5.53. In the year 1982, what is the difference between the Electricity production(% of total) in China and Electricity production(% of total) in Qatar?
Give a very brief answer. 19.46. In the year 1982, what is the difference between the Electricity production(% of total) of Gabon and Electricity production(% of total) of Qatar?
Ensure brevity in your answer.  24.99. In the year 1983, what is the difference between the Electricity production(% of total) in Canada and Electricity production(% of total) in China?
Provide a succinct answer. -17.11. In the year 1983, what is the difference between the Electricity production(% of total) of Canada and Electricity production(% of total) of Gabon?
Ensure brevity in your answer.  -22.85. In the year 1983, what is the difference between the Electricity production(% of total) in Canada and Electricity production(% of total) in Qatar?
Offer a terse response. 0.82. In the year 1983, what is the difference between the Electricity production(% of total) in China and Electricity production(% of total) in Gabon?
Your answer should be very brief. -5.74. In the year 1983, what is the difference between the Electricity production(% of total) of China and Electricity production(% of total) of Qatar?
Offer a terse response. 17.93. In the year 1983, what is the difference between the Electricity production(% of total) of Gabon and Electricity production(% of total) of Qatar?
Make the answer very short. 23.67. In the year 1984, what is the difference between the Electricity production(% of total) of Canada and Electricity production(% of total) of China?
Your answer should be compact. -15.99. In the year 1984, what is the difference between the Electricity production(% of total) of Canada and Electricity production(% of total) of Gabon?
Provide a short and direct response. -21.84. In the year 1984, what is the difference between the Electricity production(% of total) in Canada and Electricity production(% of total) in Qatar?
Your answer should be compact. -0.14. In the year 1984, what is the difference between the Electricity production(% of total) in China and Electricity production(% of total) in Gabon?
Your answer should be very brief. -5.85. In the year 1984, what is the difference between the Electricity production(% of total) in China and Electricity production(% of total) in Qatar?
Make the answer very short. 15.85. In the year 1984, what is the difference between the Electricity production(% of total) of Gabon and Electricity production(% of total) of Qatar?
Give a very brief answer. 21.7. In the year 1985, what is the difference between the Electricity production(% of total) of Canada and Electricity production(% of total) of China?
Your answer should be compact. -11.54. In the year 1985, what is the difference between the Electricity production(% of total) of Canada and Electricity production(% of total) of Gabon?
Make the answer very short. -21.06. In the year 1985, what is the difference between the Electricity production(% of total) in Canada and Electricity production(% of total) in Qatar?
Your answer should be very brief. 0.69. In the year 1985, what is the difference between the Electricity production(% of total) in China and Electricity production(% of total) in Gabon?
Provide a short and direct response. -9.52. In the year 1985, what is the difference between the Electricity production(% of total) in China and Electricity production(% of total) in Qatar?
Ensure brevity in your answer.  12.23. In the year 1985, what is the difference between the Electricity production(% of total) in Gabon and Electricity production(% of total) in Qatar?
Give a very brief answer. 21.75. In the year 1986, what is the difference between the Electricity production(% of total) in Canada and Electricity production(% of total) in China?
Offer a terse response. -9.94. In the year 1986, what is the difference between the Electricity production(% of total) in Canada and Electricity production(% of total) in Gabon?
Provide a short and direct response. -20.64. In the year 1986, what is the difference between the Electricity production(% of total) in Canada and Electricity production(% of total) in Qatar?
Offer a terse response. 0.43. In the year 1986, what is the difference between the Electricity production(% of total) in China and Electricity production(% of total) in Gabon?
Offer a very short reply. -10.7. In the year 1986, what is the difference between the Electricity production(% of total) in China and Electricity production(% of total) in Qatar?
Make the answer very short. 10.37. In the year 1986, what is the difference between the Electricity production(% of total) of Gabon and Electricity production(% of total) of Qatar?
Provide a short and direct response. 21.07. In the year 1987, what is the difference between the Electricity production(% of total) of Canada and Electricity production(% of total) of China?
Your answer should be very brief. -8.33. In the year 1987, what is the difference between the Electricity production(% of total) in Canada and Electricity production(% of total) in Gabon?
Keep it short and to the point. -19.98. In the year 1987, what is the difference between the Electricity production(% of total) of Canada and Electricity production(% of total) of Qatar?
Offer a very short reply. 1.16. In the year 1987, what is the difference between the Electricity production(% of total) in China and Electricity production(% of total) in Gabon?
Make the answer very short. -11.65. In the year 1987, what is the difference between the Electricity production(% of total) in China and Electricity production(% of total) in Qatar?
Provide a succinct answer. 9.49. In the year 1987, what is the difference between the Electricity production(% of total) in Gabon and Electricity production(% of total) in Qatar?
Provide a succinct answer. 21.14. What is the ratio of the Electricity production(% of total) of Canada in 1980 to that in 1981?
Provide a succinct answer. 1.4. What is the ratio of the Electricity production(% of total) in China in 1980 to that in 1981?
Ensure brevity in your answer.  1.05. What is the ratio of the Electricity production(% of total) in Gabon in 1980 to that in 1981?
Your answer should be compact. 1.66. What is the ratio of the Electricity production(% of total) in Qatar in 1980 to that in 1981?
Provide a succinct answer. 1.3. What is the ratio of the Electricity production(% of total) of Canada in 1980 to that in 1982?
Provide a short and direct response. 1.32. What is the ratio of the Electricity production(% of total) of China in 1980 to that in 1982?
Provide a succinct answer. 1.2. What is the ratio of the Electricity production(% of total) of Gabon in 1980 to that in 1982?
Keep it short and to the point. 1.89. What is the ratio of the Electricity production(% of total) in Qatar in 1980 to that in 1982?
Your response must be concise. 1.35. What is the ratio of the Electricity production(% of total) in Canada in 1980 to that in 1983?
Make the answer very short. 1.75. What is the ratio of the Electricity production(% of total) in China in 1980 to that in 1983?
Make the answer very short. 1.34. What is the ratio of the Electricity production(% of total) in Gabon in 1980 to that in 1983?
Provide a short and direct response. 2.04. What is the ratio of the Electricity production(% of total) of Qatar in 1980 to that in 1983?
Give a very brief answer. 2.07. What is the ratio of the Electricity production(% of total) of Canada in 1980 to that in 1984?
Provide a succinct answer. 2.58. What is the ratio of the Electricity production(% of total) of China in 1980 to that in 1984?
Provide a succinct answer. 1.48. What is the ratio of the Electricity production(% of total) of Gabon in 1980 to that in 1984?
Provide a succinct answer. 2.19. What is the ratio of the Electricity production(% of total) of Qatar in 1980 to that in 1984?
Offer a terse response. 1.71. What is the ratio of the Electricity production(% of total) of Canada in 1980 to that in 1985?
Offer a very short reply. 2.5. What is the ratio of the Electricity production(% of total) of China in 1980 to that in 1985?
Ensure brevity in your answer.  1.98. What is the ratio of the Electricity production(% of total) of Gabon in 1980 to that in 1985?
Keep it short and to the point. 2.26. What is the ratio of the Electricity production(% of total) in Qatar in 1980 to that in 1985?
Offer a very short reply. 3.43. What is the ratio of the Electricity production(% of total) of Canada in 1980 to that in 1986?
Make the answer very short. 2.81. What is the ratio of the Electricity production(% of total) in China in 1980 to that in 1986?
Offer a terse response. 2.29. What is the ratio of the Electricity production(% of total) of Gabon in 1980 to that in 1986?
Your response must be concise. 2.32. What is the ratio of the Electricity production(% of total) in Qatar in 1980 to that in 1986?
Your answer should be compact. 3.04. What is the ratio of the Electricity production(% of total) in Canada in 1980 to that in 1987?
Provide a short and direct response. 1.82. What is the ratio of the Electricity production(% of total) in China in 1980 to that in 1987?
Give a very brief answer. 2.49. What is the ratio of the Electricity production(% of total) in Gabon in 1980 to that in 1987?
Offer a terse response. 2.31. What is the ratio of the Electricity production(% of total) in Qatar in 1980 to that in 1987?
Your answer should be very brief. 3.09. What is the ratio of the Electricity production(% of total) of Canada in 1981 to that in 1982?
Ensure brevity in your answer.  0.94. What is the ratio of the Electricity production(% of total) in China in 1981 to that in 1982?
Your answer should be compact. 1.14. What is the ratio of the Electricity production(% of total) in Gabon in 1981 to that in 1982?
Make the answer very short. 1.14. What is the ratio of the Electricity production(% of total) in Qatar in 1981 to that in 1982?
Provide a short and direct response. 1.04. What is the ratio of the Electricity production(% of total) of Canada in 1981 to that in 1983?
Your answer should be compact. 1.25. What is the ratio of the Electricity production(% of total) in China in 1981 to that in 1983?
Your answer should be compact. 1.27. What is the ratio of the Electricity production(% of total) of Gabon in 1981 to that in 1983?
Provide a short and direct response. 1.23. What is the ratio of the Electricity production(% of total) in Qatar in 1981 to that in 1983?
Your answer should be very brief. 1.59. What is the ratio of the Electricity production(% of total) of Canada in 1981 to that in 1984?
Offer a terse response. 1.85. What is the ratio of the Electricity production(% of total) of China in 1981 to that in 1984?
Ensure brevity in your answer.  1.4. What is the ratio of the Electricity production(% of total) of Gabon in 1981 to that in 1984?
Keep it short and to the point. 1.32. What is the ratio of the Electricity production(% of total) of Qatar in 1981 to that in 1984?
Offer a very short reply. 1.32. What is the ratio of the Electricity production(% of total) of Canada in 1981 to that in 1985?
Give a very brief answer. 1.79. What is the ratio of the Electricity production(% of total) in China in 1981 to that in 1985?
Ensure brevity in your answer.  1.88. What is the ratio of the Electricity production(% of total) of Gabon in 1981 to that in 1985?
Offer a terse response. 1.36. What is the ratio of the Electricity production(% of total) of Qatar in 1981 to that in 1985?
Your answer should be very brief. 2.63. What is the ratio of the Electricity production(% of total) in Canada in 1981 to that in 1986?
Offer a very short reply. 2.01. What is the ratio of the Electricity production(% of total) of China in 1981 to that in 1986?
Provide a succinct answer. 2.17. What is the ratio of the Electricity production(% of total) of Gabon in 1981 to that in 1986?
Offer a terse response. 1.4. What is the ratio of the Electricity production(% of total) in Qatar in 1981 to that in 1986?
Make the answer very short. 2.33. What is the ratio of the Electricity production(% of total) of Canada in 1981 to that in 1987?
Keep it short and to the point. 1.31. What is the ratio of the Electricity production(% of total) in China in 1981 to that in 1987?
Keep it short and to the point. 2.36. What is the ratio of the Electricity production(% of total) of Gabon in 1981 to that in 1987?
Give a very brief answer. 1.4. What is the ratio of the Electricity production(% of total) of Qatar in 1981 to that in 1987?
Your answer should be very brief. 2.38. What is the ratio of the Electricity production(% of total) of Canada in 1982 to that in 1983?
Your answer should be compact. 1.32. What is the ratio of the Electricity production(% of total) of China in 1982 to that in 1983?
Offer a terse response. 1.12. What is the ratio of the Electricity production(% of total) of Gabon in 1982 to that in 1983?
Your answer should be very brief. 1.08. What is the ratio of the Electricity production(% of total) in Qatar in 1982 to that in 1983?
Ensure brevity in your answer.  1.54. What is the ratio of the Electricity production(% of total) of Canada in 1982 to that in 1984?
Provide a succinct answer. 1.96. What is the ratio of the Electricity production(% of total) of China in 1982 to that in 1984?
Provide a succinct answer. 1.23. What is the ratio of the Electricity production(% of total) of Gabon in 1982 to that in 1984?
Ensure brevity in your answer.  1.16. What is the ratio of the Electricity production(% of total) of Qatar in 1982 to that in 1984?
Provide a succinct answer. 1.27. What is the ratio of the Electricity production(% of total) in Canada in 1982 to that in 1985?
Your response must be concise. 1.9. What is the ratio of the Electricity production(% of total) of China in 1982 to that in 1985?
Offer a very short reply. 1.65. What is the ratio of the Electricity production(% of total) of Gabon in 1982 to that in 1985?
Your answer should be very brief. 1.2. What is the ratio of the Electricity production(% of total) of Qatar in 1982 to that in 1985?
Your response must be concise. 2.54. What is the ratio of the Electricity production(% of total) in Canada in 1982 to that in 1986?
Offer a terse response. 2.13. What is the ratio of the Electricity production(% of total) of China in 1982 to that in 1986?
Your answer should be very brief. 1.91. What is the ratio of the Electricity production(% of total) of Gabon in 1982 to that in 1986?
Give a very brief answer. 1.23. What is the ratio of the Electricity production(% of total) in Qatar in 1982 to that in 1986?
Offer a very short reply. 2.25. What is the ratio of the Electricity production(% of total) of Canada in 1982 to that in 1987?
Give a very brief answer. 1.38. What is the ratio of the Electricity production(% of total) of China in 1982 to that in 1987?
Make the answer very short. 2.07. What is the ratio of the Electricity production(% of total) in Gabon in 1982 to that in 1987?
Your answer should be compact. 1.23. What is the ratio of the Electricity production(% of total) in Qatar in 1982 to that in 1987?
Offer a terse response. 2.29. What is the ratio of the Electricity production(% of total) of Canada in 1983 to that in 1984?
Your answer should be very brief. 1.48. What is the ratio of the Electricity production(% of total) of China in 1983 to that in 1984?
Make the answer very short. 1.1. What is the ratio of the Electricity production(% of total) of Gabon in 1983 to that in 1984?
Offer a very short reply. 1.07. What is the ratio of the Electricity production(% of total) in Qatar in 1983 to that in 1984?
Offer a terse response. 0.83. What is the ratio of the Electricity production(% of total) in Canada in 1983 to that in 1985?
Ensure brevity in your answer.  1.43. What is the ratio of the Electricity production(% of total) in China in 1983 to that in 1985?
Make the answer very short. 1.48. What is the ratio of the Electricity production(% of total) in Gabon in 1983 to that in 1985?
Make the answer very short. 1.11. What is the ratio of the Electricity production(% of total) of Qatar in 1983 to that in 1985?
Ensure brevity in your answer.  1.65. What is the ratio of the Electricity production(% of total) in Canada in 1983 to that in 1986?
Your response must be concise. 1.61. What is the ratio of the Electricity production(% of total) in China in 1983 to that in 1986?
Your answer should be very brief. 1.71. What is the ratio of the Electricity production(% of total) in Gabon in 1983 to that in 1986?
Your answer should be very brief. 1.14. What is the ratio of the Electricity production(% of total) in Qatar in 1983 to that in 1986?
Give a very brief answer. 1.46. What is the ratio of the Electricity production(% of total) in Canada in 1983 to that in 1987?
Make the answer very short. 1.04. What is the ratio of the Electricity production(% of total) in China in 1983 to that in 1987?
Your answer should be compact. 1.86. What is the ratio of the Electricity production(% of total) in Gabon in 1983 to that in 1987?
Your response must be concise. 1.13. What is the ratio of the Electricity production(% of total) of Qatar in 1983 to that in 1987?
Offer a very short reply. 1.49. What is the ratio of the Electricity production(% of total) in Canada in 1984 to that in 1985?
Ensure brevity in your answer.  0.97. What is the ratio of the Electricity production(% of total) in China in 1984 to that in 1985?
Give a very brief answer. 1.34. What is the ratio of the Electricity production(% of total) of Gabon in 1984 to that in 1985?
Ensure brevity in your answer.  1.03. What is the ratio of the Electricity production(% of total) of Qatar in 1984 to that in 1985?
Give a very brief answer. 2. What is the ratio of the Electricity production(% of total) in Canada in 1984 to that in 1986?
Your answer should be very brief. 1.09. What is the ratio of the Electricity production(% of total) of China in 1984 to that in 1986?
Provide a succinct answer. 1.55. What is the ratio of the Electricity production(% of total) of Gabon in 1984 to that in 1986?
Make the answer very short. 1.06. What is the ratio of the Electricity production(% of total) in Qatar in 1984 to that in 1986?
Your answer should be very brief. 1.77. What is the ratio of the Electricity production(% of total) of Canada in 1984 to that in 1987?
Make the answer very short. 0.71. What is the ratio of the Electricity production(% of total) of China in 1984 to that in 1987?
Offer a terse response. 1.68. What is the ratio of the Electricity production(% of total) of Gabon in 1984 to that in 1987?
Your answer should be very brief. 1.06. What is the ratio of the Electricity production(% of total) in Qatar in 1984 to that in 1987?
Provide a short and direct response. 1.81. What is the ratio of the Electricity production(% of total) in Canada in 1985 to that in 1986?
Your answer should be very brief. 1.12. What is the ratio of the Electricity production(% of total) of China in 1985 to that in 1986?
Ensure brevity in your answer.  1.16. What is the ratio of the Electricity production(% of total) of Gabon in 1985 to that in 1986?
Make the answer very short. 1.03. What is the ratio of the Electricity production(% of total) in Qatar in 1985 to that in 1986?
Ensure brevity in your answer.  0.89. What is the ratio of the Electricity production(% of total) in Canada in 1985 to that in 1987?
Give a very brief answer. 0.73. What is the ratio of the Electricity production(% of total) of China in 1985 to that in 1987?
Offer a terse response. 1.26. What is the ratio of the Electricity production(% of total) of Gabon in 1985 to that in 1987?
Provide a short and direct response. 1.02. What is the ratio of the Electricity production(% of total) of Qatar in 1985 to that in 1987?
Provide a succinct answer. 0.9. What is the ratio of the Electricity production(% of total) of Canada in 1986 to that in 1987?
Offer a terse response. 0.65. What is the ratio of the Electricity production(% of total) in China in 1986 to that in 1987?
Make the answer very short. 1.09. What is the ratio of the Electricity production(% of total) in Qatar in 1986 to that in 1987?
Make the answer very short. 1.02. What is the difference between the highest and the second highest Electricity production(% of total) of Canada?
Your response must be concise. 0.89. What is the difference between the highest and the second highest Electricity production(% of total) in China?
Offer a very short reply. 1.34. What is the difference between the highest and the second highest Electricity production(% of total) in Gabon?
Give a very brief answer. 20.19. What is the difference between the highest and the second highest Electricity production(% of total) in Qatar?
Make the answer very short. 0.62. What is the difference between the highest and the lowest Electricity production(% of total) of Canada?
Give a very brief answer. 2.38. What is the difference between the highest and the lowest Electricity production(% of total) of China?
Offer a terse response. 15.45. What is the difference between the highest and the lowest Electricity production(% of total) in Gabon?
Ensure brevity in your answer.  28.98. What is the difference between the highest and the lowest Electricity production(% of total) in Qatar?
Provide a short and direct response. 1.91. 